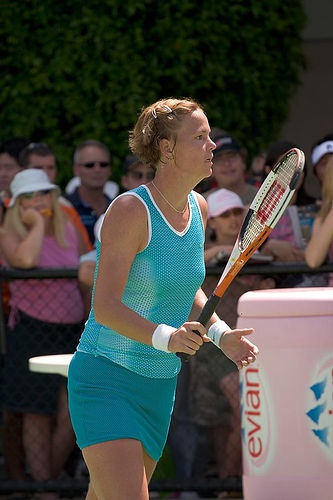Describe the objects in this image and their specific colors. I can see people in black, gray, teal, and brown tones, people in black, brown, and purple tones, tennis racket in black, darkgray, brown, and gray tones, people in black, maroon, gray, and darkgray tones, and people in black, gray, and maroon tones in this image. 